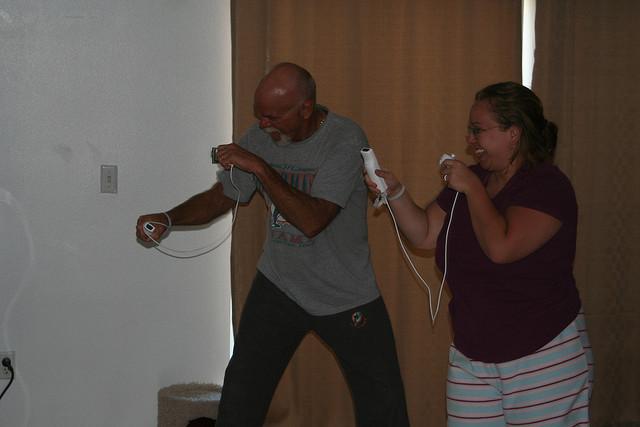Is that a married couple?
Answer briefly. Yes. What is touching the right arm of the man?
Write a very short answer. Wall. What is the guy holding in his hand?
Answer briefly. Wii remote. What is in her hand?
Short answer required. Game controller. What color is the door?
Be succinct. Brown. How many archers are pictured?
Be succinct. 0. Is she taking a selfie?
Quick response, please. No. Is this a married couple?
Short answer required. Yes. Which sport is depicted here?
Answer briefly. Wii. What is the man pretending the Wii remote is?
Be succinct. Bat. What color are her pants?
Keep it brief. Blue. Is he at a park?
Answer briefly. No. Is the woman wearing a watch?
Keep it brief. No. Are these two posing for the photo?
Short answer required. No. What style of shorts is the man wearing?
Short answer required. No shorts. What is the man doing?
Concise answer only. Playing wii. Do you think the lady is enjoying herself?
Be succinct. Yes. Where is the person?
Short answer required. Room. What color is the top that the woman is wearing?
Give a very brief answer. Purple. Are both of these people women?
Keep it brief. No. What is the girl doing?
Quick response, please. Playing wii. Is the complete wall up?
Give a very brief answer. Yes. Is the woman wearing a jacket?
Keep it brief. No. Is the man wearing a shirt?
Short answer required. Yes. What team is on the man's shirt?
Short answer required. Miami dolphins. What color is the lady's shirt?
Be succinct. Purple. Are both people laughing?
Concise answer only. Yes. What is this person doing?
Quick response, please. Playing wii. Do these two normally have an easy time finding dates?
Answer briefly. Yes. What color is the girl's pants?
Be succinct. Grey with red stripes. What is hanging from the man's belt loop?
Be succinct. Nothing. Are these adults or children?
Give a very brief answer. Adults. What device is this person holding?
Short answer required. Wii remote. How many people are there?
Answer briefly. 2. What color is the lady's jacket?
Concise answer only. Purple. What is the girl holding on to?
Concise answer only. Controller. What is in the women's hands?
Quick response, please. Wii controller. What race is this man?
Concise answer only. White. How many women are playing?
Be succinct. 1. What is the man holding?
Be succinct. Wii remote. How many people are female?
Give a very brief answer. 1. What color is the man's shirt?
Keep it brief. Gray. Where is this picture taken?
Give a very brief answer. Living room. What does the girl have in her hair?
Give a very brief answer. Scrunchie. Is this a couple?
Concise answer only. Yes. Is the woman inside or outside?
Short answer required. Inside. Is this man resting?
Be succinct. No. Are these two fighting?
Concise answer only. No. Where is the woman looking?
Concise answer only. Tv. What game system are they playing?
Write a very short answer. Wii. Are they playing the video games drunk?
Give a very brief answer. No. Is the woman a blonde or a brunette?
Write a very short answer. Brunette. What does the woman have in her hand?
Answer briefly. Wii controller. Is someone getting an award?
Give a very brief answer. No. Is this girl standing with her grandfather?
Be succinct. Yes. What type of wall is in the background?
Be succinct. White. What does the man have his arm around?
Quick response, please. Wiimote. What is the color of the clothes she is wearing?
Keep it brief. Black and white. 